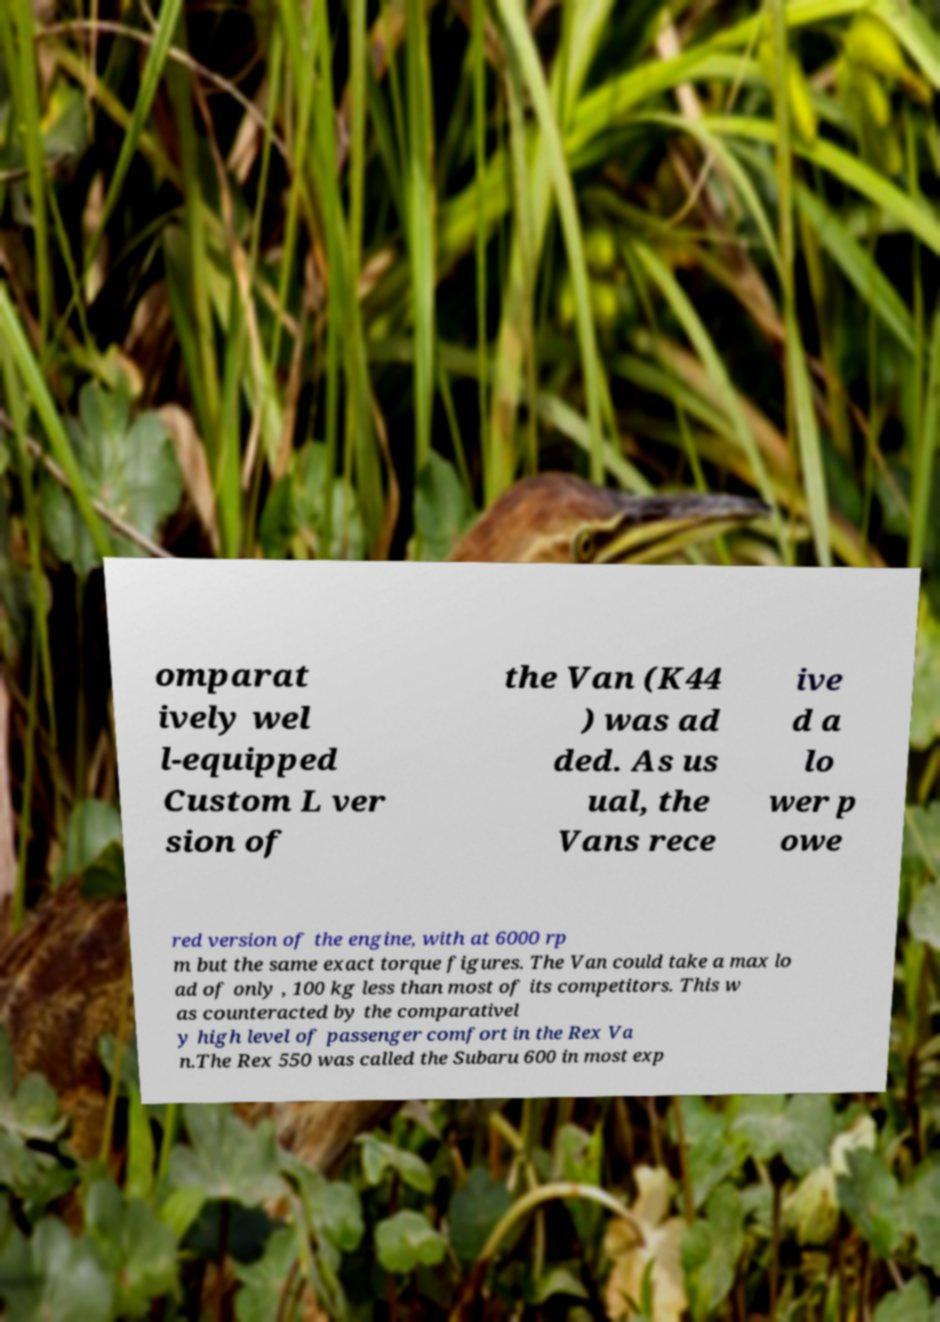Please identify and transcribe the text found in this image. omparat ively wel l-equipped Custom L ver sion of the Van (K44 ) was ad ded. As us ual, the Vans rece ive d a lo wer p owe red version of the engine, with at 6000 rp m but the same exact torque figures. The Van could take a max lo ad of only , 100 kg less than most of its competitors. This w as counteracted by the comparativel y high level of passenger comfort in the Rex Va n.The Rex 550 was called the Subaru 600 in most exp 